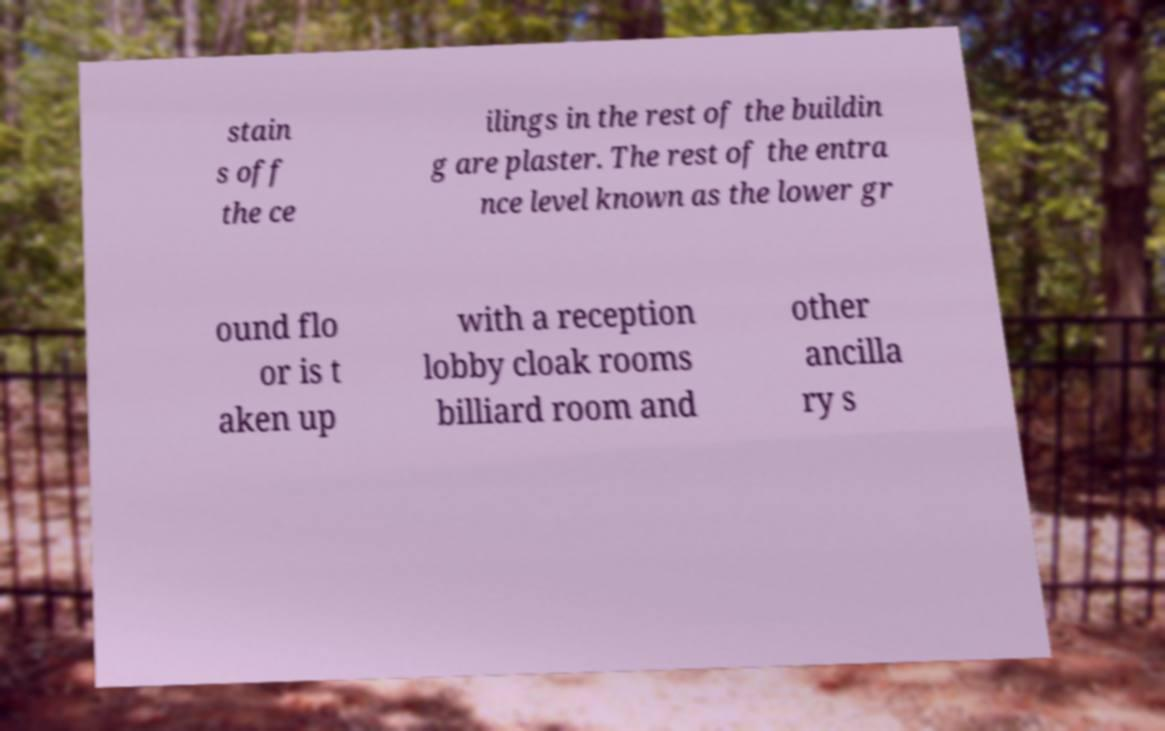I need the written content from this picture converted into text. Can you do that? stain s off the ce ilings in the rest of the buildin g are plaster. The rest of the entra nce level known as the lower gr ound flo or is t aken up with a reception lobby cloak rooms billiard room and other ancilla ry s 